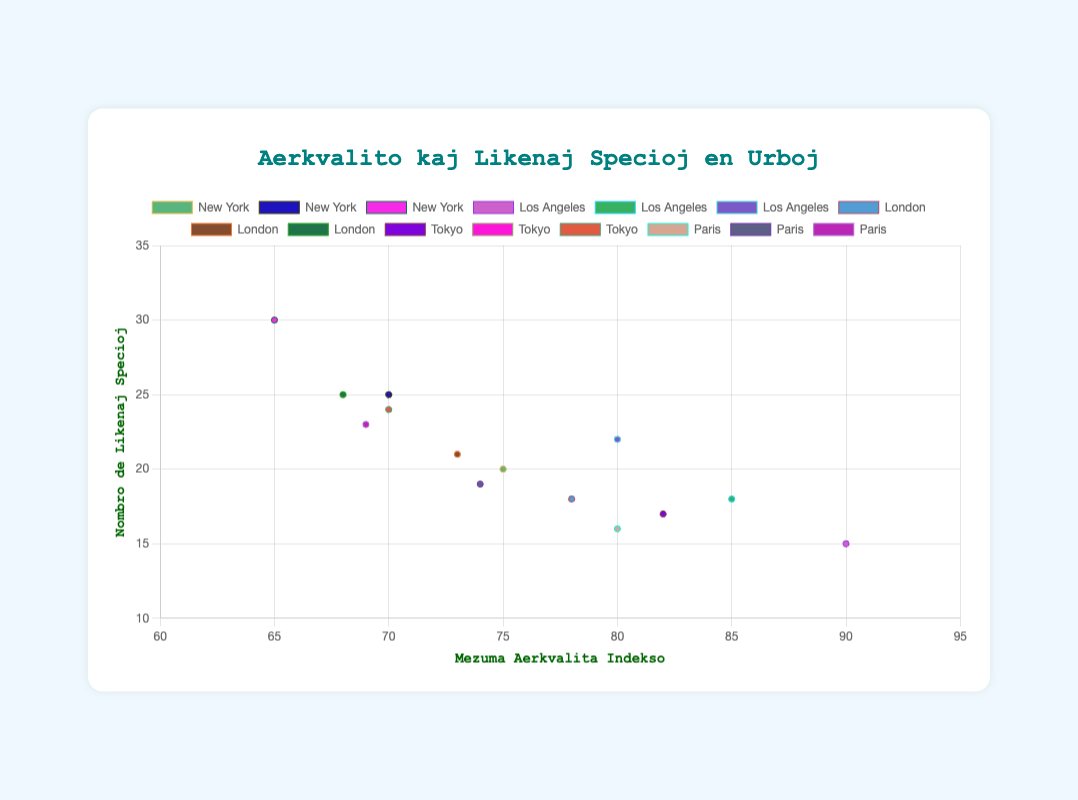What trend is observed in the average air quality index for New York from 2010 to 2020? The trend observed in the average air quality index for New York is that it decreases over the years from 75 in 2010 to 70 in 2015 and finally to 65 in 2020.
Answer: The air quality improves Compare the number of lichen species counts in New York and Los Angeles in 2020. Which city has more species? In 2020, the number of lichen species in New York is 30, while in Los Angeles, it is 22. Thus, New York has more lichen species than Los Angeles.
Answer: New York Which city experienced the largest improvement in air quality from 2010 to 2020? To determine this, we look for the city with the largest decrease in the average air quality index. New York: 75 to 65 (10 points), Los Angeles: 90 to 80 (10 points), London: 78 to 68 (10 points), Tokyo: 82 to 70 (12 points), Paris: 80 to 69 (11 points). Thus, Tokyo experienced the largest improvement.
Answer: Tokyo Is there a general correlation between air quality and lichen species count across the cities? By looking at the scatter plot, a general correlation can be observed: as the air quality index decreases (indicating better air quality), the number of lichen species tends to increase. This suggests a positive correlation between better air quality and higher lichen species diversity.
Answer: Positive correlation What is the difference in lichen species count between Tokyo and Paris in 2015? In 2015, Tokyo has 20 lichen species, and Paris has 19 lichen species. The difference is 20 - 19 = 1 species.
Answer: 1 species Which city shows the largest increase in lichen species from 2010 to 2020? Comparing the increase in lichen species from 2010 to 2020 for each city: New York: 20 to 30 (10 species), Los Angeles: 15 to 22 (7 species), London: 18 to 25 (7 species), Tokyo: 17 to 24 (7 species), Paris: 16 to 23 (7 species). Hence, New York shows the largest increase in lichen species.
Answer: New York Among the cities listed, which one maintained the highest average air quality index in 2010? For 2010, we compare the average air quality index values: New York (75), Los Angeles (90), London (78), Tokyo (82), Paris (80). Los Angeles had the highest value.
Answer: Los Angeles How many lichen species were recorded in Los Angeles and London combined in 2020? In 2020, Los Angeles recorded 22 lichen species and London recorded 25. Combined, it is 22 + 25 = 47 species.
Answer: 47 species Which city had the lowest number of lichen species in 2010, and what was the air quality index for that city at that time? In 2010, Los Angeles had the lowest number of lichen species with 15. The air quality index for Los Angeles in 2010 was 90.
Answer: Los Angeles with AQI 90 Compare New York's air quality index improvement with Paris from 2010 to 2020. Which city's air quality improved more? New York's air quality index improved by 10 points (from 75 to 65) from 2010 to 2020. Paris's air quality index improved by 11 points (from 80 to 69) from 2010 to 2020. Thus, Paris's air quality improved more.
Answer: Paris 